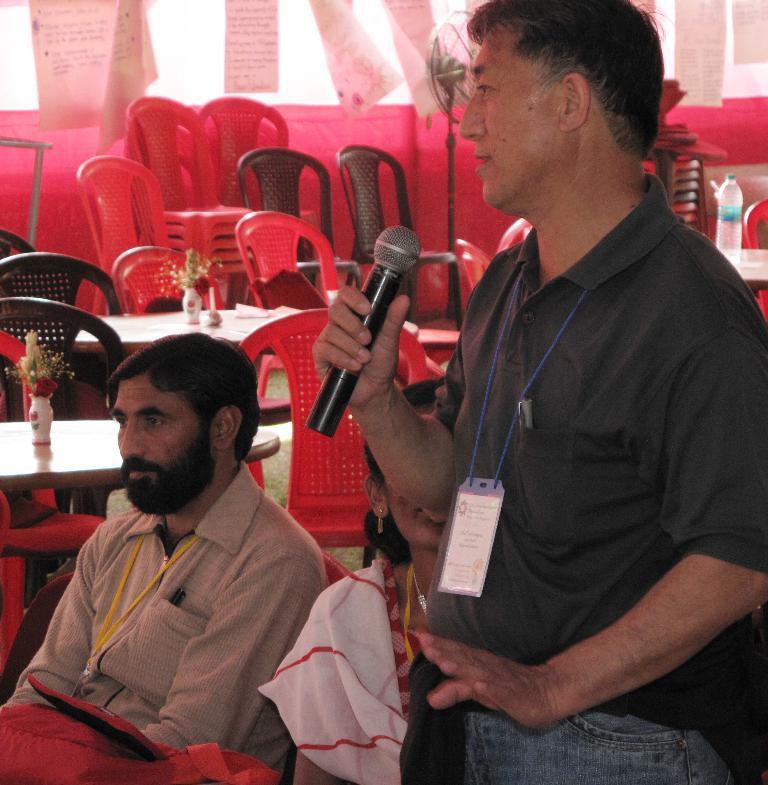How would you summarize this image in a sentence or two? In this image we can see one person is holding the microphone, beside that we can see two people sitting, beside that we can see tables and few objects on it. And we can see chairs, towards that we can see a fan. And we can see text written on the papers. 